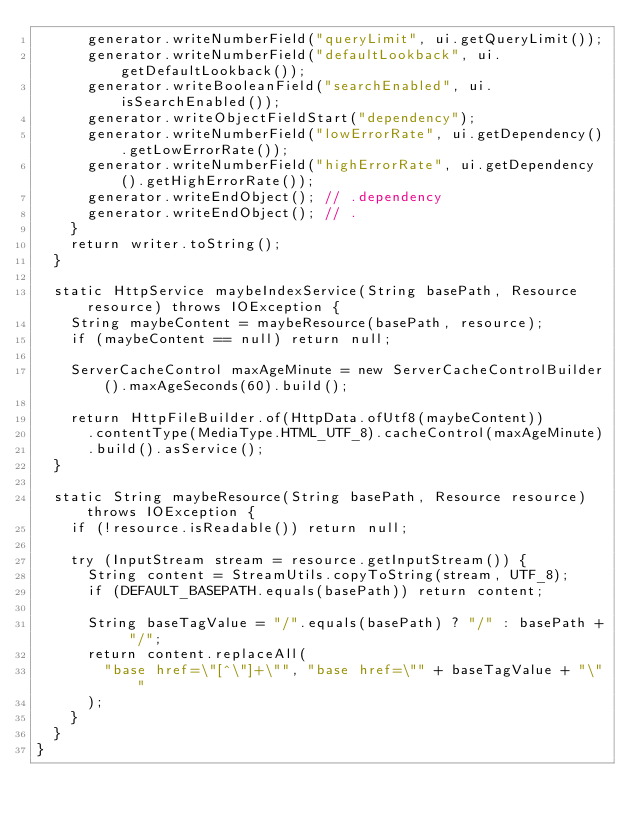<code> <loc_0><loc_0><loc_500><loc_500><_Java_>      generator.writeNumberField("queryLimit", ui.getQueryLimit());
      generator.writeNumberField("defaultLookback", ui.getDefaultLookback());
      generator.writeBooleanField("searchEnabled", ui.isSearchEnabled());
      generator.writeObjectFieldStart("dependency");
      generator.writeNumberField("lowErrorRate", ui.getDependency().getLowErrorRate());
      generator.writeNumberField("highErrorRate", ui.getDependency().getHighErrorRate());
      generator.writeEndObject(); // .dependency
      generator.writeEndObject(); // .
    }
    return writer.toString();
  }

  static HttpService maybeIndexService(String basePath, Resource resource) throws IOException {
    String maybeContent = maybeResource(basePath, resource);
    if (maybeContent == null) return null;

    ServerCacheControl maxAgeMinute = new ServerCacheControlBuilder().maxAgeSeconds(60).build();

    return HttpFileBuilder.of(HttpData.ofUtf8(maybeContent))
      .contentType(MediaType.HTML_UTF_8).cacheControl(maxAgeMinute)
      .build().asService();
  }

  static String maybeResource(String basePath, Resource resource) throws IOException {
    if (!resource.isReadable()) return null;

    try (InputStream stream = resource.getInputStream()) {
      String content = StreamUtils.copyToString(stream, UTF_8);
      if (DEFAULT_BASEPATH.equals(basePath)) return content;

      String baseTagValue = "/".equals(basePath) ? "/" : basePath + "/";
      return content.replaceAll(
        "base href=\"[^\"]+\"", "base href=\"" + baseTagValue + "\""
      );
    }
  }
}
</code> 